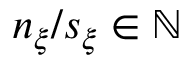<formula> <loc_0><loc_0><loc_500><loc_500>n _ { \xi } / s _ { \xi } \in \mathbb { N }</formula> 